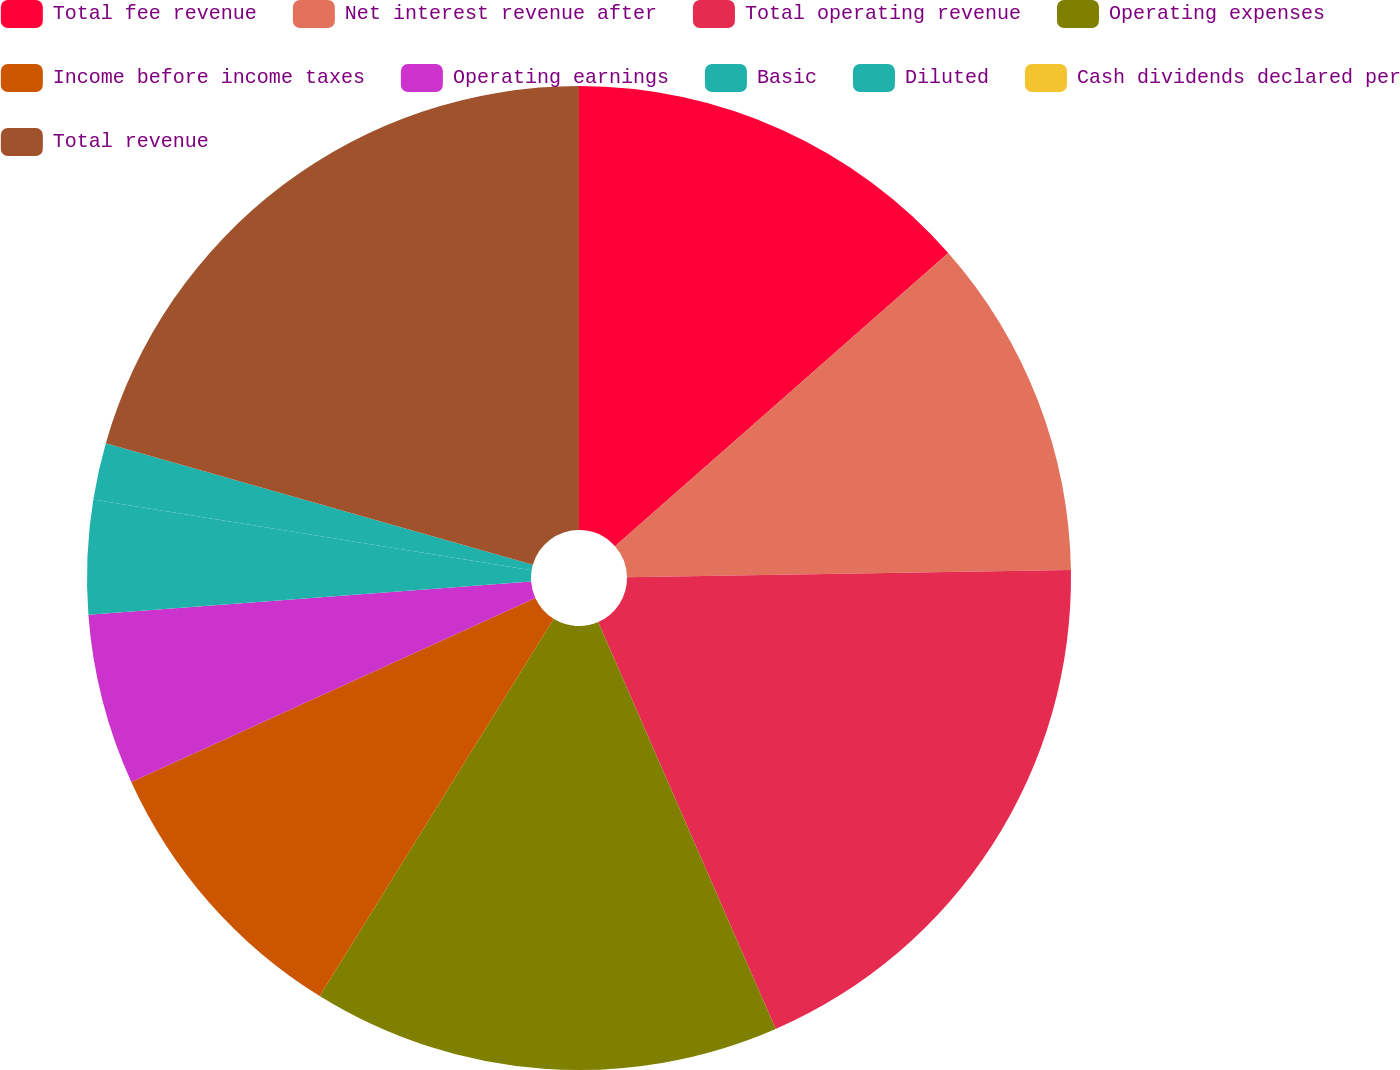Convert chart to OTSL. <chart><loc_0><loc_0><loc_500><loc_500><pie_chart><fcel>Total fee revenue<fcel>Net interest revenue after<fcel>Total operating revenue<fcel>Operating expenses<fcel>Income before income taxes<fcel>Operating earnings<fcel>Basic<fcel>Diluted<fcel>Cash dividends declared per<fcel>Total revenue<nl><fcel>13.51%<fcel>11.23%<fcel>18.71%<fcel>15.38%<fcel>9.36%<fcel>5.61%<fcel>3.74%<fcel>1.87%<fcel>0.0%<fcel>20.58%<nl></chart> 